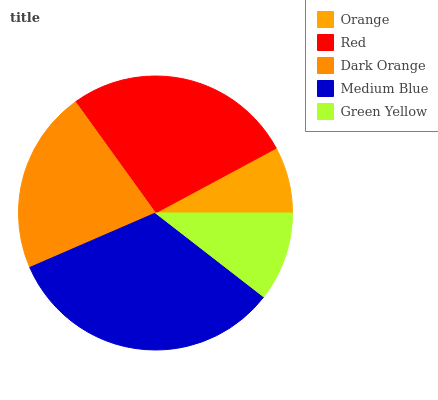Is Orange the minimum?
Answer yes or no. Yes. Is Medium Blue the maximum?
Answer yes or no. Yes. Is Red the minimum?
Answer yes or no. No. Is Red the maximum?
Answer yes or no. No. Is Red greater than Orange?
Answer yes or no. Yes. Is Orange less than Red?
Answer yes or no. Yes. Is Orange greater than Red?
Answer yes or no. No. Is Red less than Orange?
Answer yes or no. No. Is Dark Orange the high median?
Answer yes or no. Yes. Is Dark Orange the low median?
Answer yes or no. Yes. Is Orange the high median?
Answer yes or no. No. Is Orange the low median?
Answer yes or no. No. 